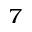Convert formula to latex. <formula><loc_0><loc_0><loc_500><loc_500>^ { 7 }</formula> 